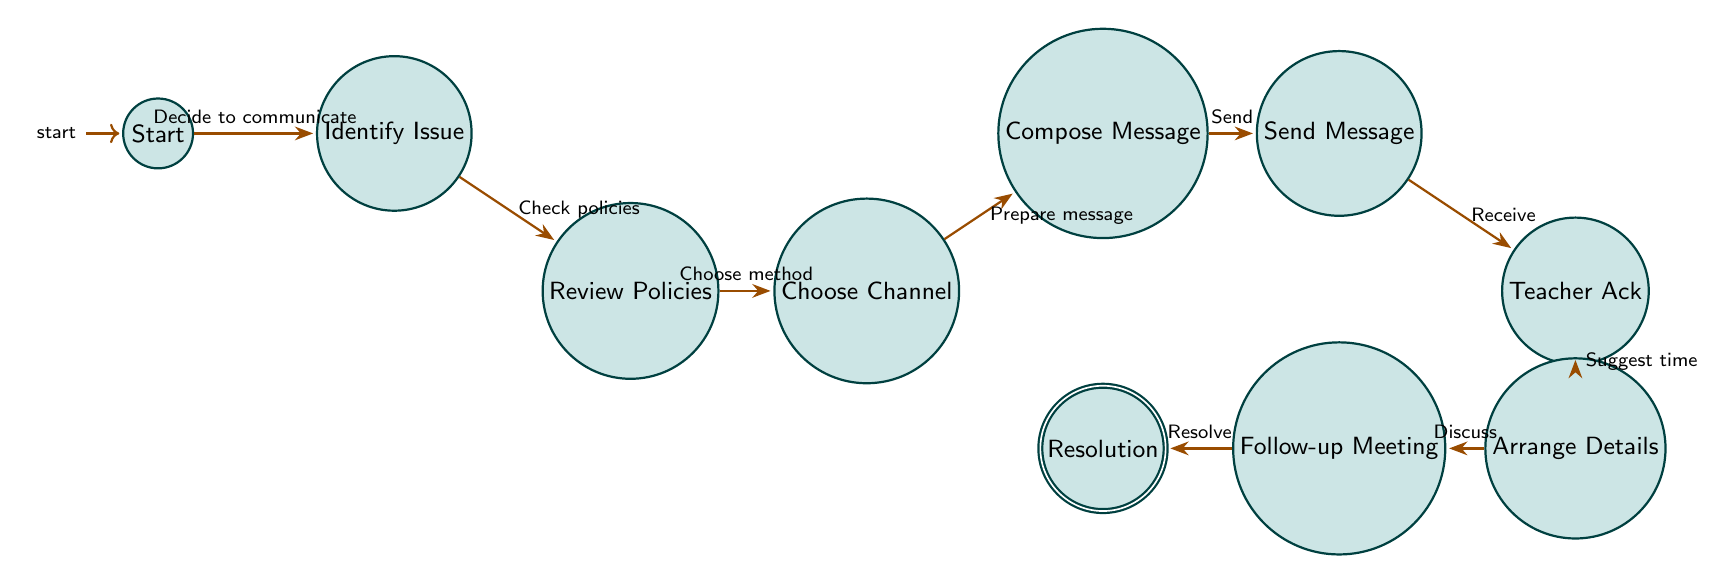What is the initial state in the diagram? The initial state is labeled as "Start," which is the first node in the finite state machine diagram.
Answer: Start How many nodes are present in the diagram? Counting each distinct state from the diagram, there are 10 nodes representing different steps in the Parent-Teacher Communication Workflow.
Answer: 10 What is the state that follows "Send Message"? After "Send Message," the next state is "Teacher Acknowledgment," which indicates the response from the teacher after receiving the message.
Answer: Teacher Acknowledgment Which state comes before "Arrange Details"? The state before "Arrange Details" is "Teacher Acknowledgment," where the teacher acknowledges the received message before suggesting a time for further discussion.
Answer: Teacher Acknowledgment What is the final state in the workflow? The final state, where the process concludes with the resolution of the issue, is labeled as "Resolution."
Answer: Resolution How does a parent start the communication process? The parent starts the communication process by entering the "Start" state, which signals the decision to communicate with the teacher.
Answer: Decide to communicate Which state requires checking school policies? The state requiring checking school policies is "Review School Policies," where the parent looks at the communication guidelines provided by the school.
Answer: Review School Policies What transition follows after composing a message? After composing a message, the next transition is to "Send Message," where the parent actually sends the drafted message through the chosen communication channel.
Answer: Send Message In what state does the teacher suggest a time for a meeting? The teacher suggests a time for a meeting in the state "Arrange Details," where the scheduling of a discussion occurs.
Answer: Arrange Details What is the transition description from "Follow Up Meeting" to "Resolution"? The transition from "Follow Up Meeting" to "Resolution" describes the process in which the issue is discussed in detail and satisfactorily resolved for both parties.
Answer: Resolve 